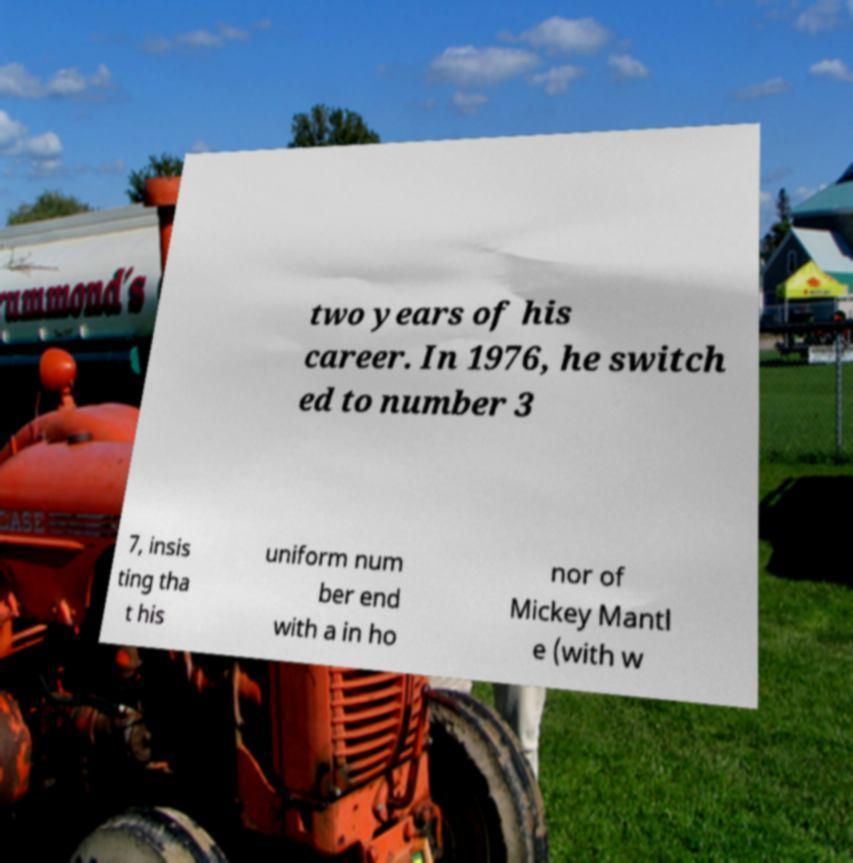What messages or text are displayed in this image? I need them in a readable, typed format. two years of his career. In 1976, he switch ed to number 3 7, insis ting tha t his uniform num ber end with a in ho nor of Mickey Mantl e (with w 